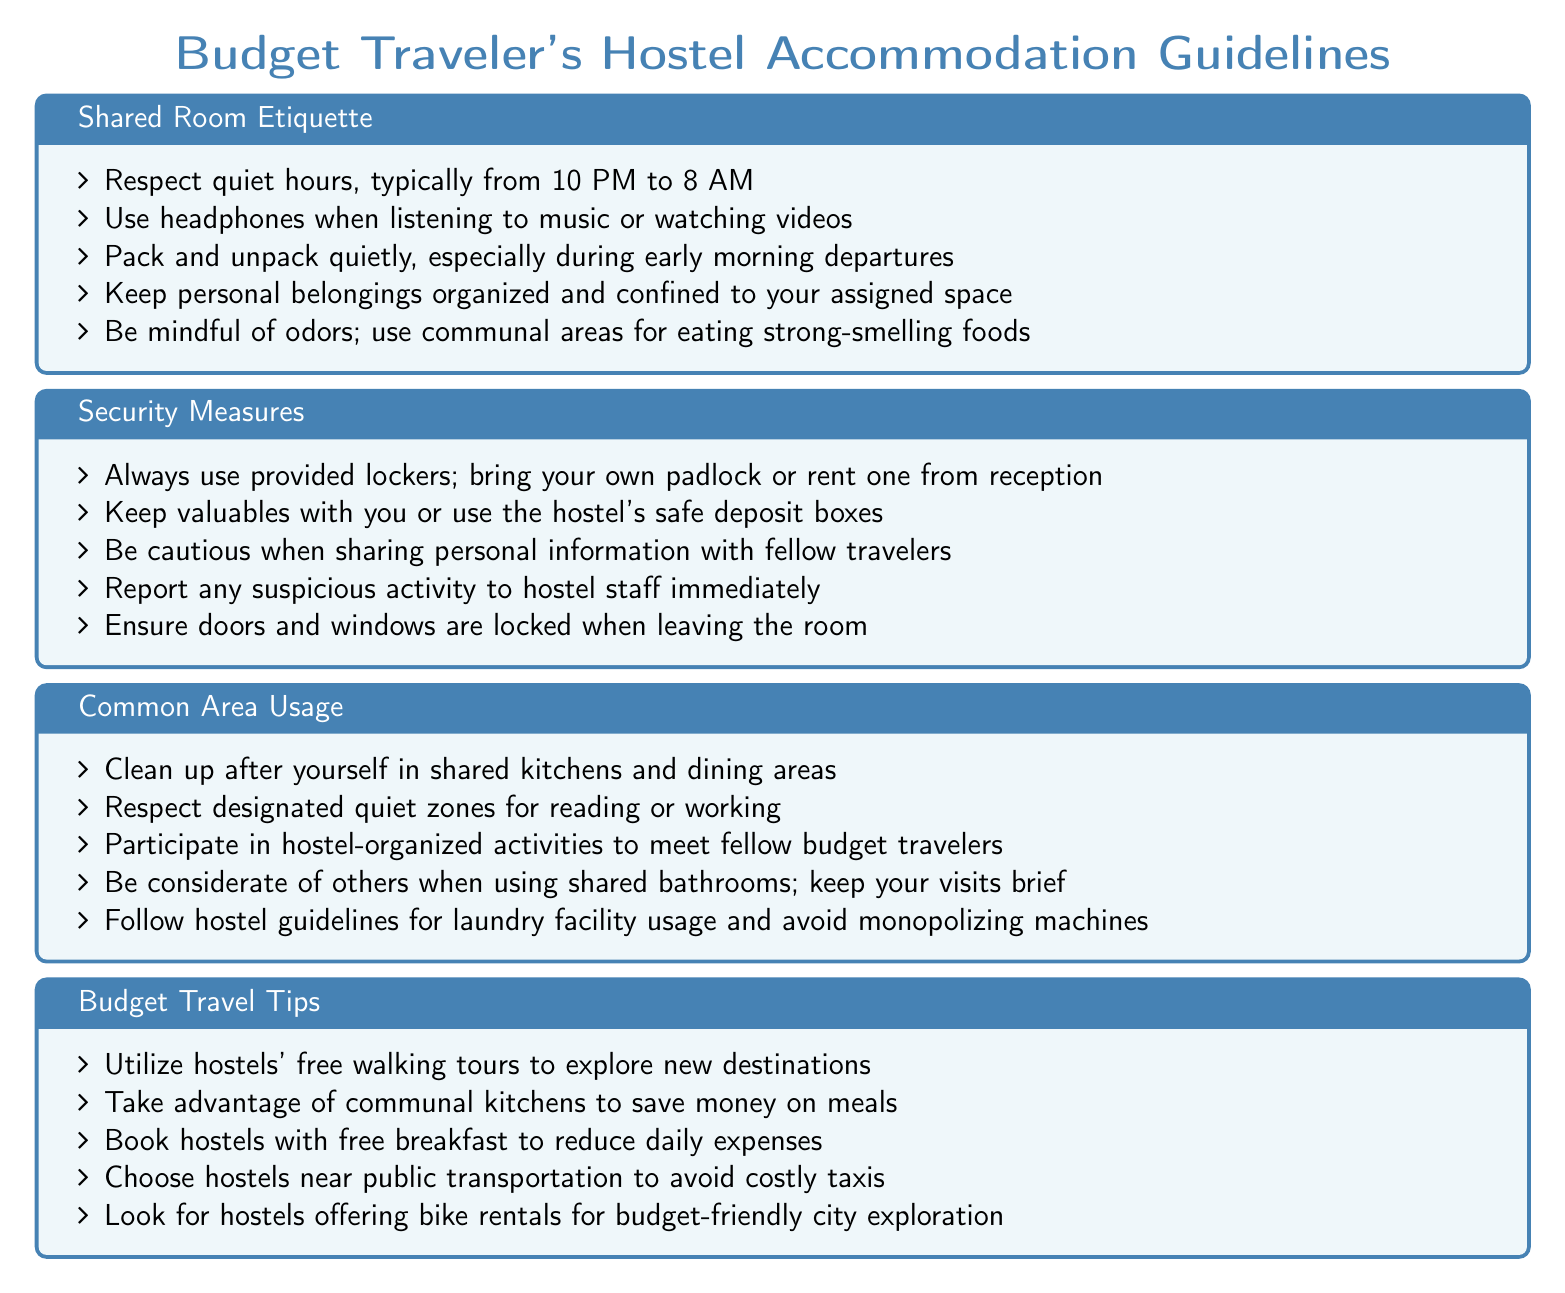What are quiet hours in the hostel? Quiet hours are times when noise should be minimized to respect others, typically set from 10 PM to 8 AM.
Answer: 10 PM to 8 AM How should personal belongings be organized in shared rooms? The document advises that personal belongings should be organized and confined to one's assigned space in shared rooms.
Answer: Assigned space What should you do with valuables when staying at the hostel? You should keep valuables with you or use the hostel's safe deposit boxes for security.
Answer: Safe deposit boxes How should you behave in shared kitchens? The guidelines state that you should clean up after yourself in shared kitchens and dining areas.
Answer: Clean up after yourself What should you do if you notice suspicious activity in the hostel? You should report any suspicious activity to hostel staff immediately for safety.
Answer: Report to staff What is the recommended action regarding strong-smelling foods? Strong-smelling foods should be eaten in communal areas instead of shared rooms.
Answer: Communal areas What should you respect in designated quiet zones? In designated quiet zones, you should respect the privacy and focus of others, typically for reading or working.
Answer: Privacy and focus What is a tip for reducing daily expenses while traveling? Booking hostels with free breakfast is a suggested tip to save money on daily expenses.
Answer: Free breakfast How can you avoid monopolizing laundry machines? You should follow hostel guidelines for laundry usage to ensure fair access to machines.
Answer: Follow guidelines 